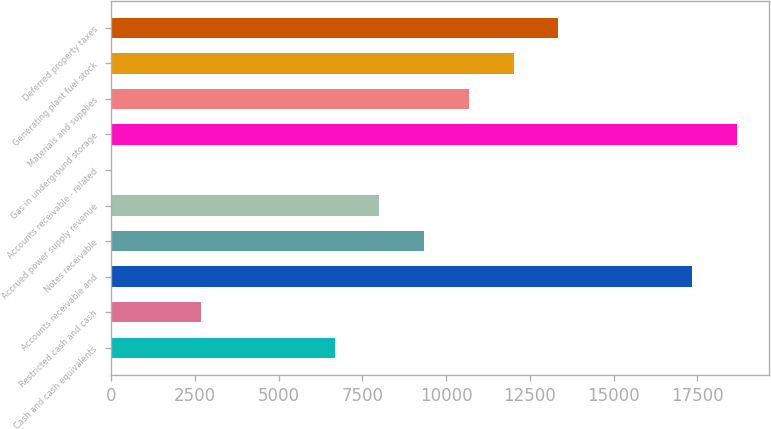<chart> <loc_0><loc_0><loc_500><loc_500><bar_chart><fcel>Cash and cash equivalents<fcel>Restricted cash and cash<fcel>Accounts receivable and<fcel>Notes receivable<fcel>Accrued power supply revenue<fcel>Accounts receivable - related<fcel>Gas in underground storage<fcel>Materials and supplies<fcel>Generating plant fuel stock<fcel>Deferred property taxes<nl><fcel>6677<fcel>2672<fcel>17357<fcel>9347<fcel>8012<fcel>2<fcel>18692<fcel>10682<fcel>12017<fcel>13352<nl></chart> 